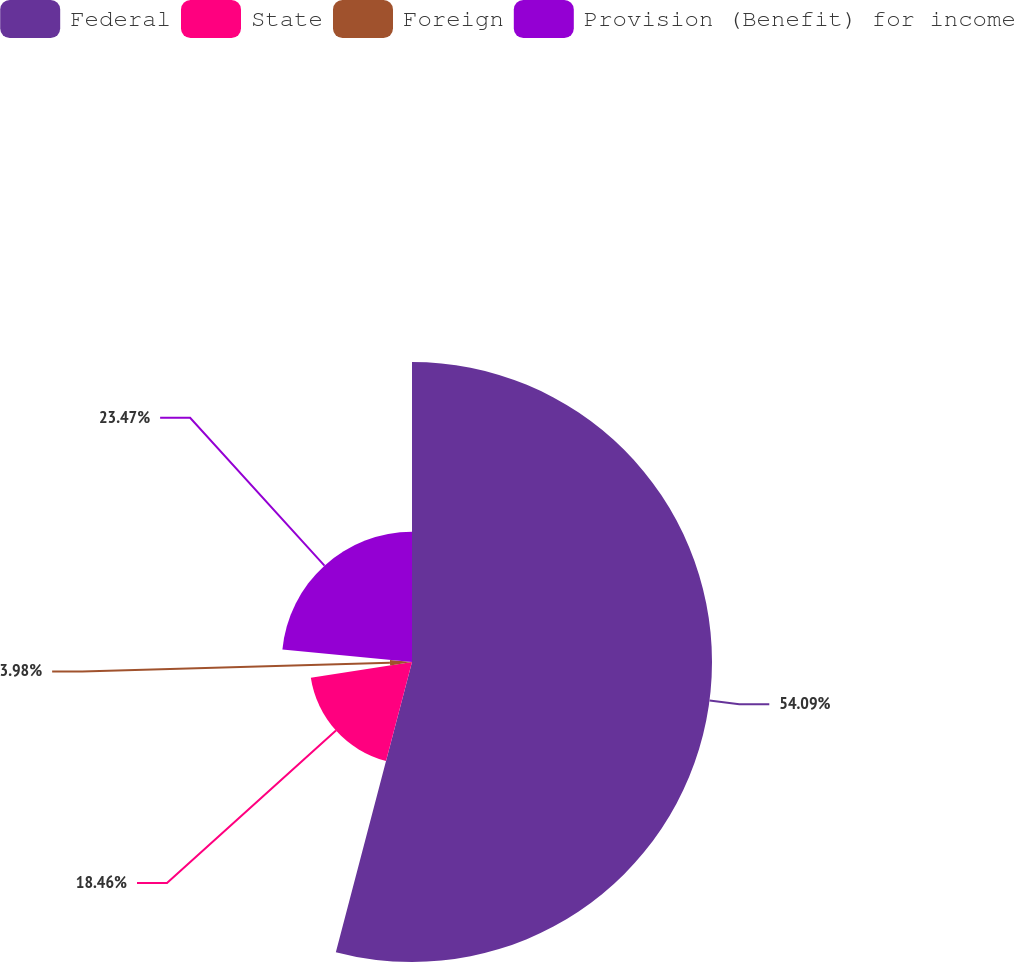Convert chart. <chart><loc_0><loc_0><loc_500><loc_500><pie_chart><fcel>Federal<fcel>State<fcel>Foreign<fcel>Provision (Benefit) for income<nl><fcel>54.08%<fcel>18.46%<fcel>3.98%<fcel>23.47%<nl></chart> 